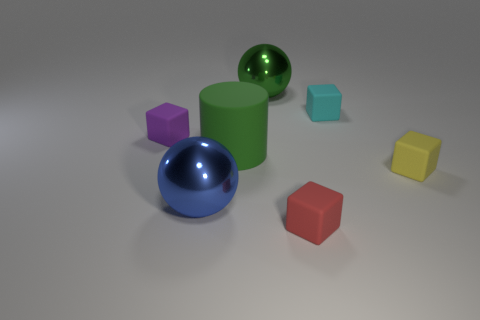How many objects are either big metallic objects that are to the left of the green sphere or large cylinders?
Give a very brief answer. 2. What is the shape of the thing that is to the right of the red rubber cube and behind the small purple rubber block?
Offer a terse response. Cube. What number of objects are small objects to the right of the red matte block or rubber things right of the large blue sphere?
Offer a terse response. 4. How many other things are the same size as the blue thing?
Make the answer very short. 2. There is a metallic sphere that is right of the big green matte cylinder; does it have the same color as the big matte cylinder?
Offer a terse response. Yes. What size is the matte cube that is in front of the small purple thing and left of the small yellow object?
Ensure brevity in your answer.  Small. How many large objects are either green things or green shiny things?
Provide a succinct answer. 2. There is a rubber object right of the tiny cyan thing; what is its shape?
Keep it short and to the point. Cube. How many tiny purple spheres are there?
Offer a terse response. 0. Does the yellow cube have the same material as the big green cylinder?
Give a very brief answer. Yes. 